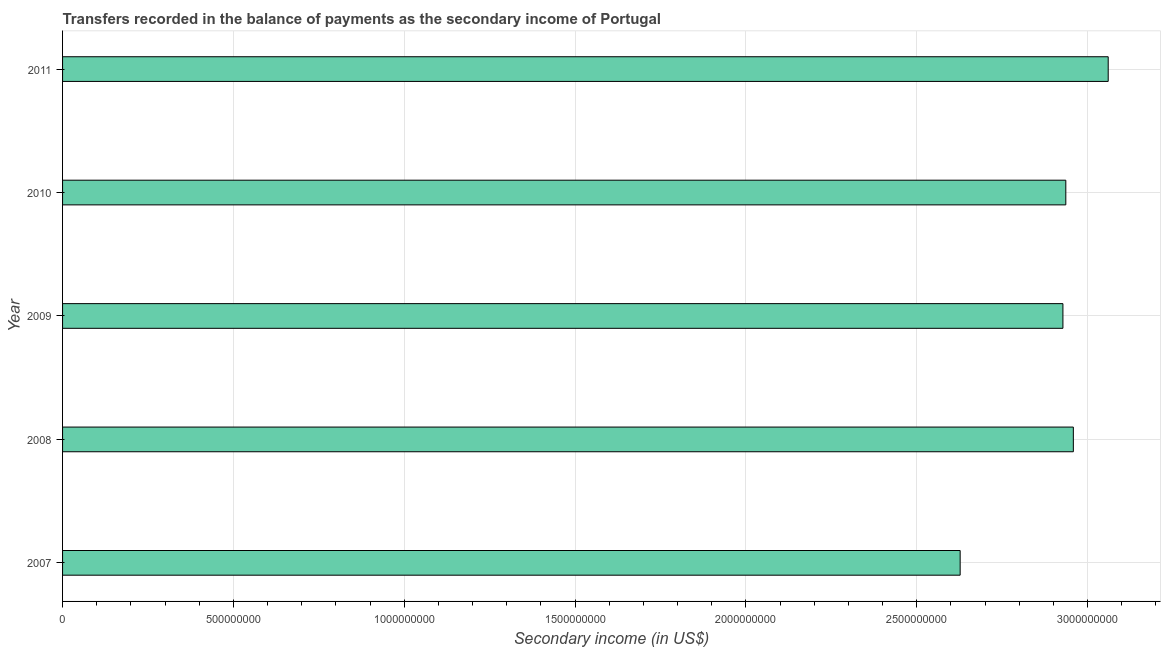Does the graph contain any zero values?
Offer a very short reply. No. Does the graph contain grids?
Your response must be concise. Yes. What is the title of the graph?
Offer a terse response. Transfers recorded in the balance of payments as the secondary income of Portugal. What is the label or title of the X-axis?
Provide a succinct answer. Secondary income (in US$). What is the label or title of the Y-axis?
Provide a succinct answer. Year. What is the amount of secondary income in 2008?
Ensure brevity in your answer.  2.96e+09. Across all years, what is the maximum amount of secondary income?
Provide a short and direct response. 3.06e+09. Across all years, what is the minimum amount of secondary income?
Ensure brevity in your answer.  2.63e+09. What is the sum of the amount of secondary income?
Keep it short and to the point. 1.45e+1. What is the difference between the amount of secondary income in 2009 and 2010?
Make the answer very short. -8.47e+06. What is the average amount of secondary income per year?
Your answer should be compact. 2.90e+09. What is the median amount of secondary income?
Ensure brevity in your answer.  2.94e+09. In how many years, is the amount of secondary income greater than 200000000 US$?
Your answer should be very brief. 5. What is the ratio of the amount of secondary income in 2008 to that in 2009?
Offer a terse response. 1.01. Is the amount of secondary income in 2010 less than that in 2011?
Provide a succinct answer. Yes. What is the difference between the highest and the second highest amount of secondary income?
Your answer should be very brief. 1.02e+08. Is the sum of the amount of secondary income in 2008 and 2011 greater than the maximum amount of secondary income across all years?
Your answer should be very brief. Yes. What is the difference between the highest and the lowest amount of secondary income?
Provide a succinct answer. 4.33e+08. In how many years, is the amount of secondary income greater than the average amount of secondary income taken over all years?
Provide a short and direct response. 4. How many bars are there?
Provide a short and direct response. 5. How many years are there in the graph?
Your answer should be very brief. 5. Are the values on the major ticks of X-axis written in scientific E-notation?
Provide a short and direct response. No. What is the Secondary income (in US$) in 2007?
Keep it short and to the point. 2.63e+09. What is the Secondary income (in US$) of 2008?
Your answer should be very brief. 2.96e+09. What is the Secondary income (in US$) in 2009?
Provide a short and direct response. 2.93e+09. What is the Secondary income (in US$) in 2010?
Offer a very short reply. 2.94e+09. What is the Secondary income (in US$) of 2011?
Provide a short and direct response. 3.06e+09. What is the difference between the Secondary income (in US$) in 2007 and 2008?
Offer a very short reply. -3.31e+08. What is the difference between the Secondary income (in US$) in 2007 and 2009?
Your answer should be compact. -3.01e+08. What is the difference between the Secondary income (in US$) in 2007 and 2010?
Make the answer very short. -3.09e+08. What is the difference between the Secondary income (in US$) in 2007 and 2011?
Keep it short and to the point. -4.33e+08. What is the difference between the Secondary income (in US$) in 2008 and 2009?
Keep it short and to the point. 3.05e+07. What is the difference between the Secondary income (in US$) in 2008 and 2010?
Make the answer very short. 2.20e+07. What is the difference between the Secondary income (in US$) in 2008 and 2011?
Provide a succinct answer. -1.02e+08. What is the difference between the Secondary income (in US$) in 2009 and 2010?
Offer a very short reply. -8.47e+06. What is the difference between the Secondary income (in US$) in 2009 and 2011?
Make the answer very short. -1.33e+08. What is the difference between the Secondary income (in US$) in 2010 and 2011?
Provide a succinct answer. -1.24e+08. What is the ratio of the Secondary income (in US$) in 2007 to that in 2008?
Your answer should be compact. 0.89. What is the ratio of the Secondary income (in US$) in 2007 to that in 2009?
Your answer should be very brief. 0.9. What is the ratio of the Secondary income (in US$) in 2007 to that in 2010?
Offer a terse response. 0.9. What is the ratio of the Secondary income (in US$) in 2007 to that in 2011?
Offer a terse response. 0.86. What is the ratio of the Secondary income (in US$) in 2008 to that in 2009?
Give a very brief answer. 1.01. What is the ratio of the Secondary income (in US$) in 2009 to that in 2010?
Your answer should be very brief. 1. What is the ratio of the Secondary income (in US$) in 2010 to that in 2011?
Offer a very short reply. 0.96. 